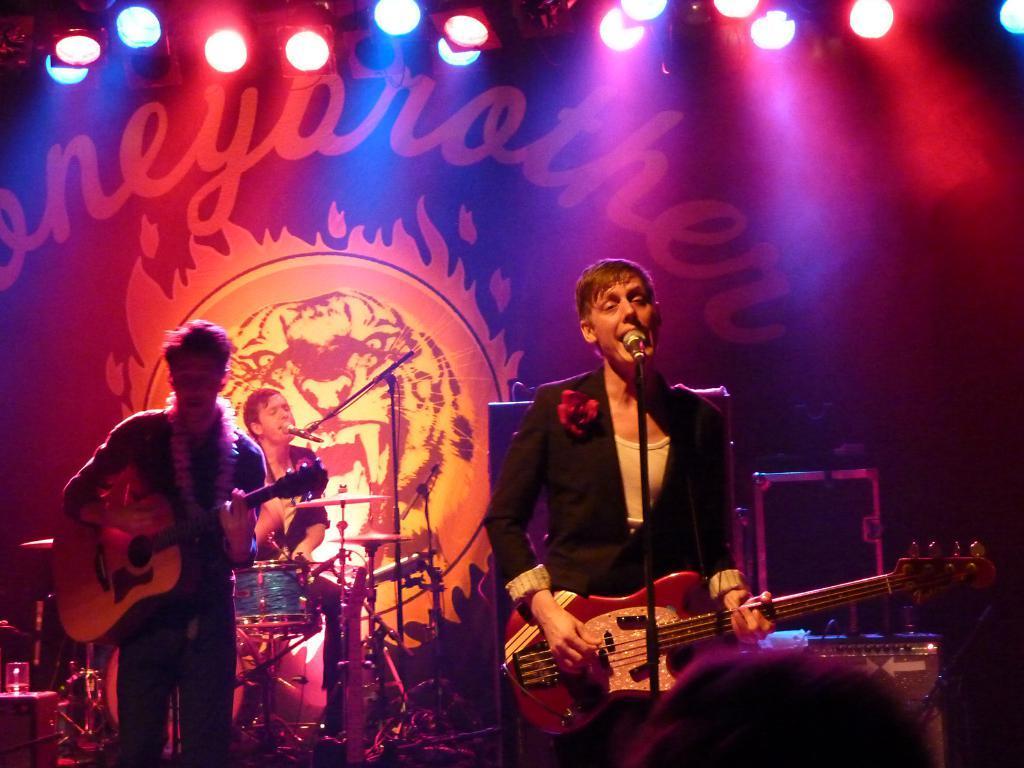Describe this image in one or two sentences. In this picture, here we see 3 men who are looking like singing. Here the right person is holding the guitar and he is singing behind a microphone. In the center we have a person sitting and playing drums. At the left we have small stool on which glass of water is present. This seems like audience head. And it is like musical concert. 